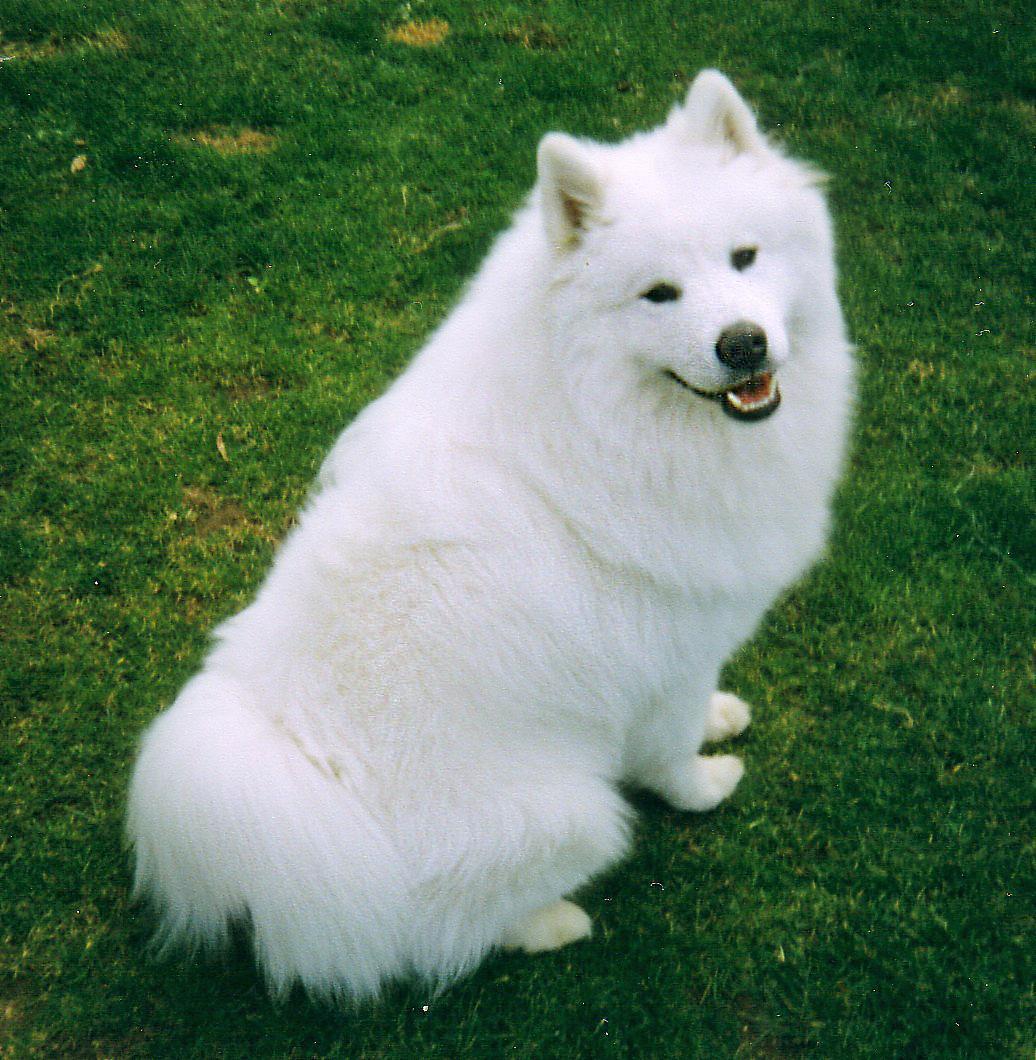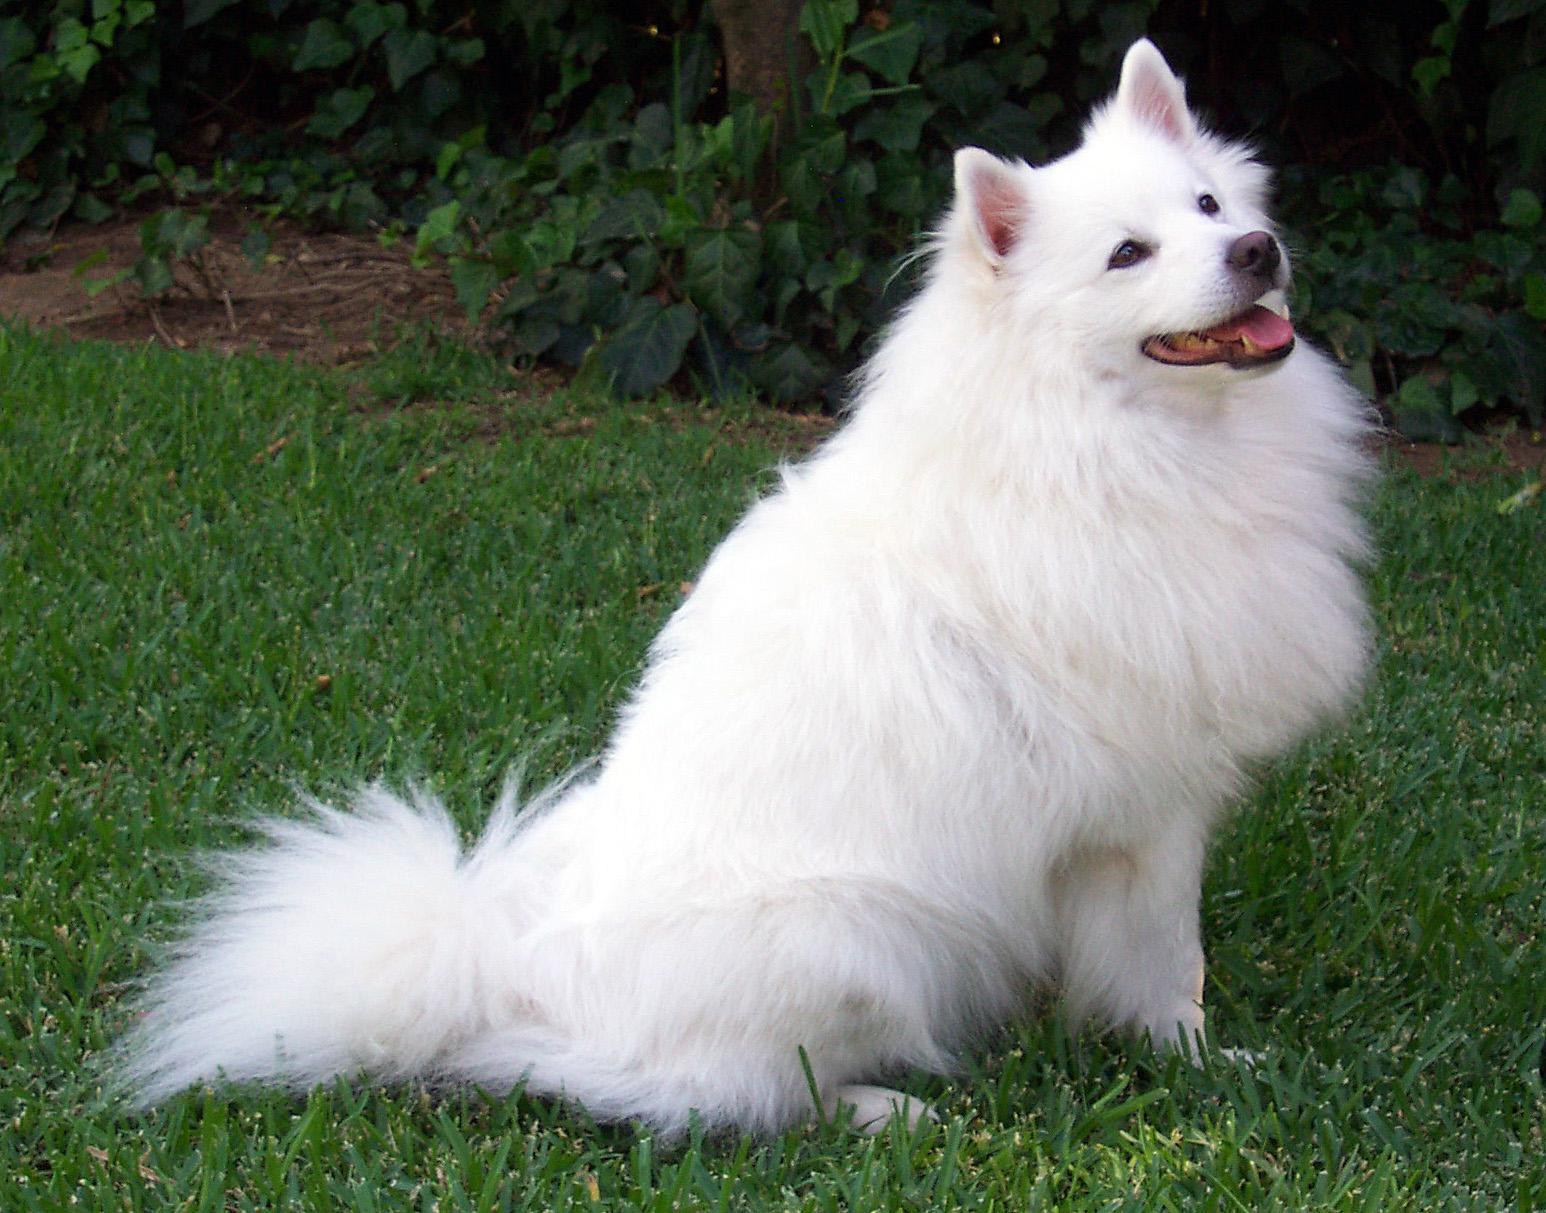The first image is the image on the left, the second image is the image on the right. For the images displayed, is the sentence "At least one of the images shows a dog sitting." factually correct? Answer yes or no. Yes. The first image is the image on the left, the second image is the image on the right. Examine the images to the left and right. Is the description "All white dogs are sitting in green grass." accurate? Answer yes or no. Yes. 